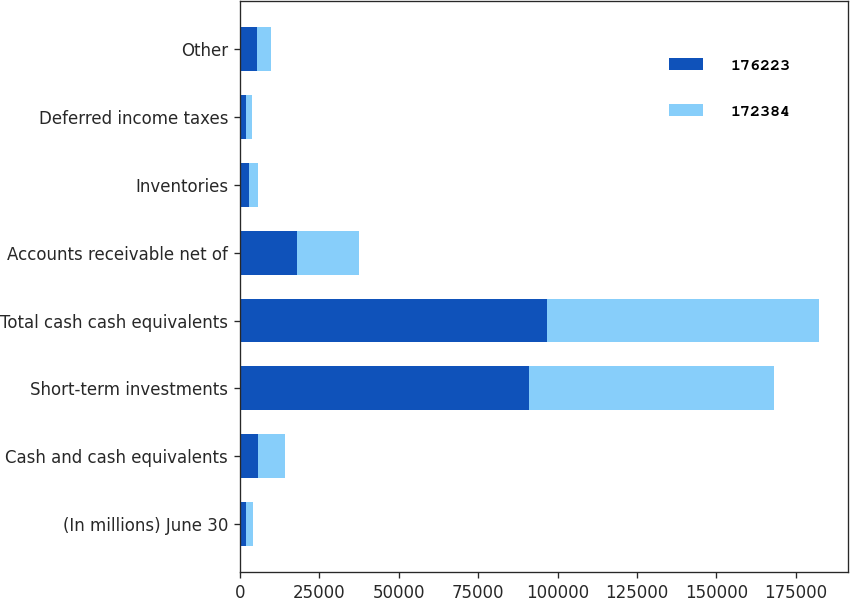Convert chart. <chart><loc_0><loc_0><loc_500><loc_500><stacked_bar_chart><ecel><fcel>(In millions) June 30<fcel>Cash and cash equivalents<fcel>Short-term investments<fcel>Total cash cash equivalents<fcel>Accounts receivable net of<fcel>Inventories<fcel>Deferred income taxes<fcel>Other<nl><fcel>176223<fcel>2015<fcel>5595<fcel>90931<fcel>96526<fcel>17908<fcel>2902<fcel>1915<fcel>5461<nl><fcel>172384<fcel>2014<fcel>8669<fcel>77040<fcel>85709<fcel>19544<fcel>2660<fcel>1941<fcel>4392<nl></chart> 